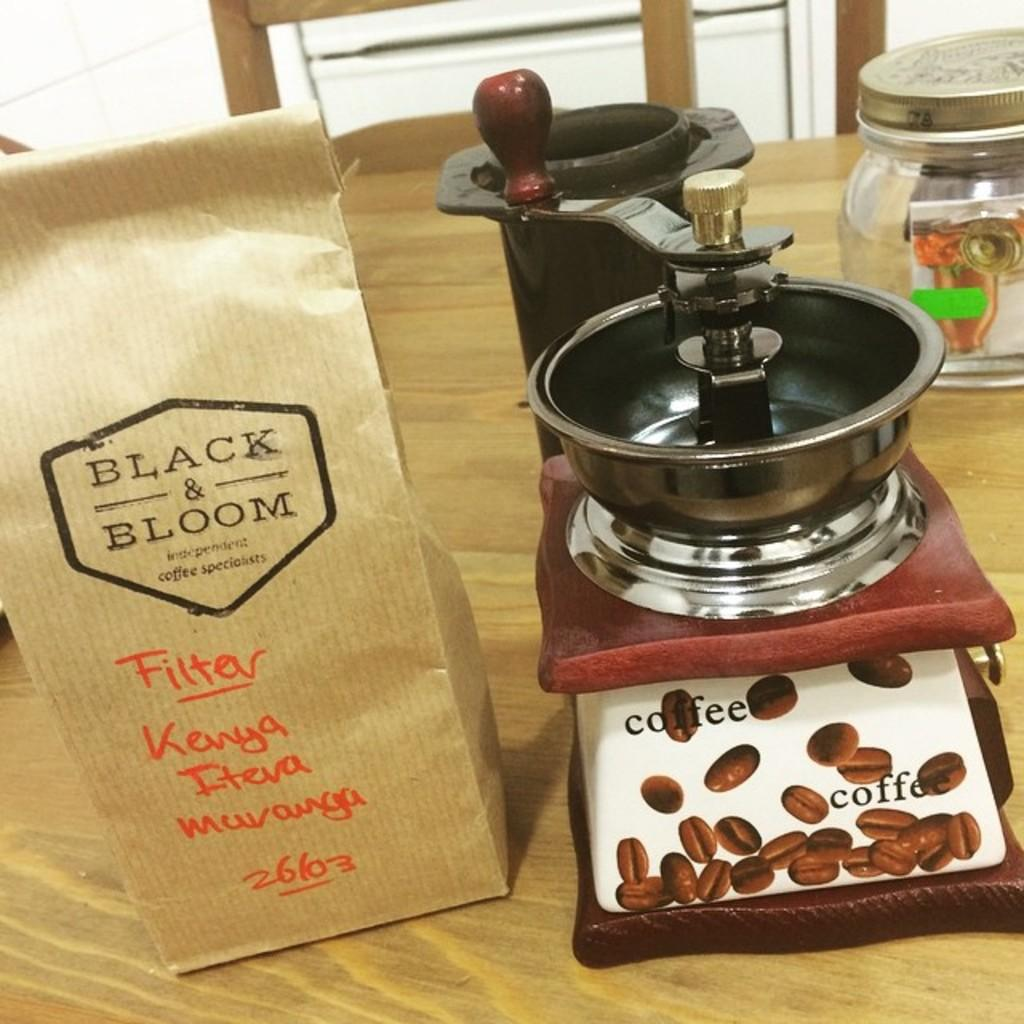<image>
Describe the image concisely. A packet of Black & Bloom coffee rests on a wooden table. 